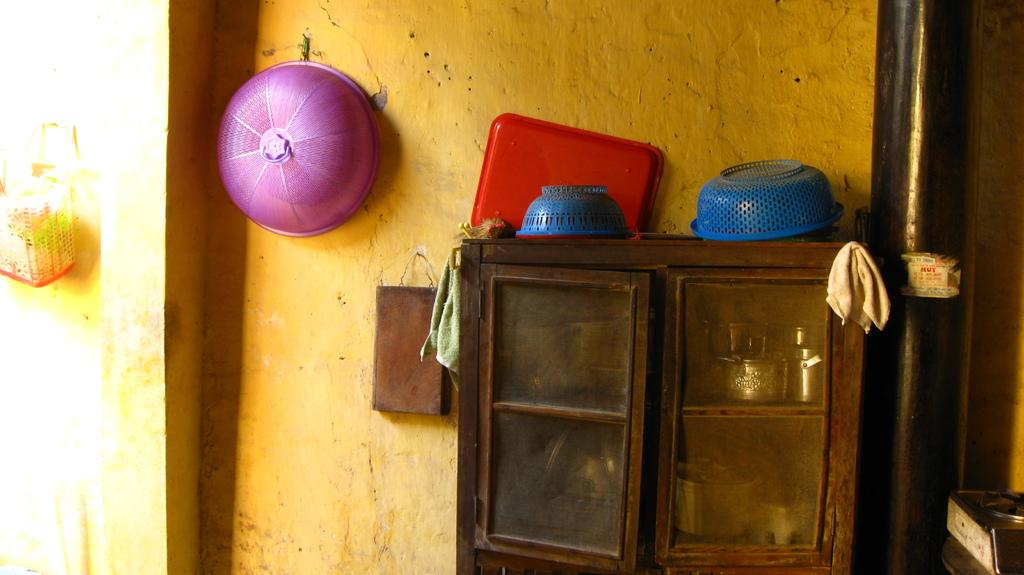What objects are present in the image that are used for storage or organization? There are baskets and racks in the image. Can you describe the pipe on the wall in the image? Yes, there is a pipe on the wall in the image. What type of sofa can be seen in the image? There is no sofa present in the image. Is there any liquid visible in the image? There is no liquid visible in the image. 